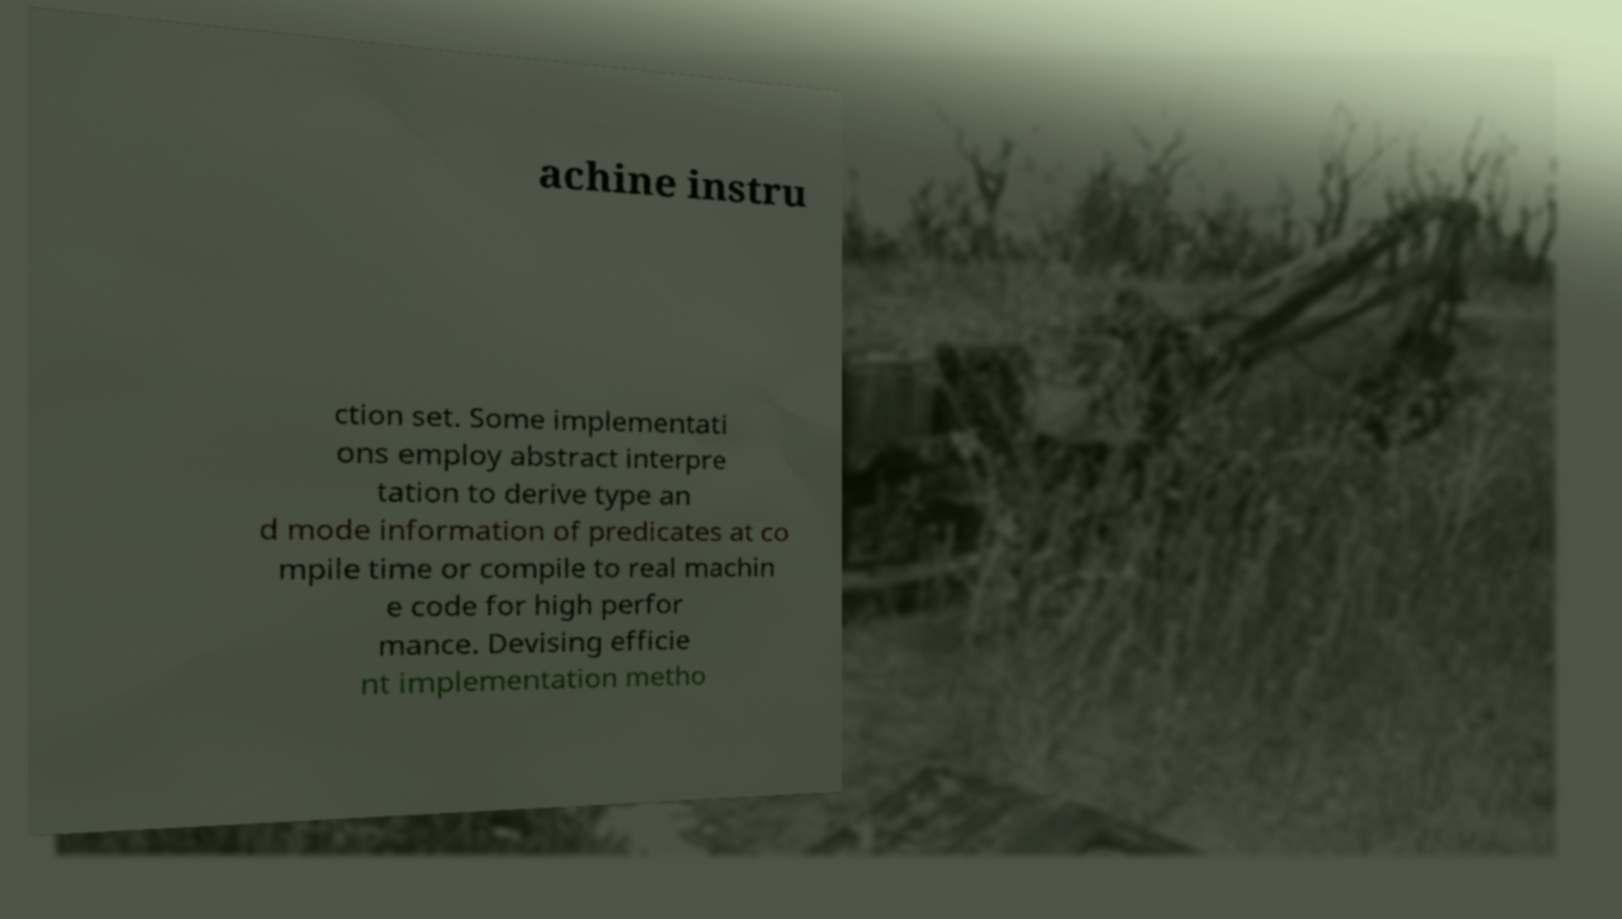Can you accurately transcribe the text from the provided image for me? achine instru ction set. Some implementati ons employ abstract interpre tation to derive type an d mode information of predicates at co mpile time or compile to real machin e code for high perfor mance. Devising efficie nt implementation metho 